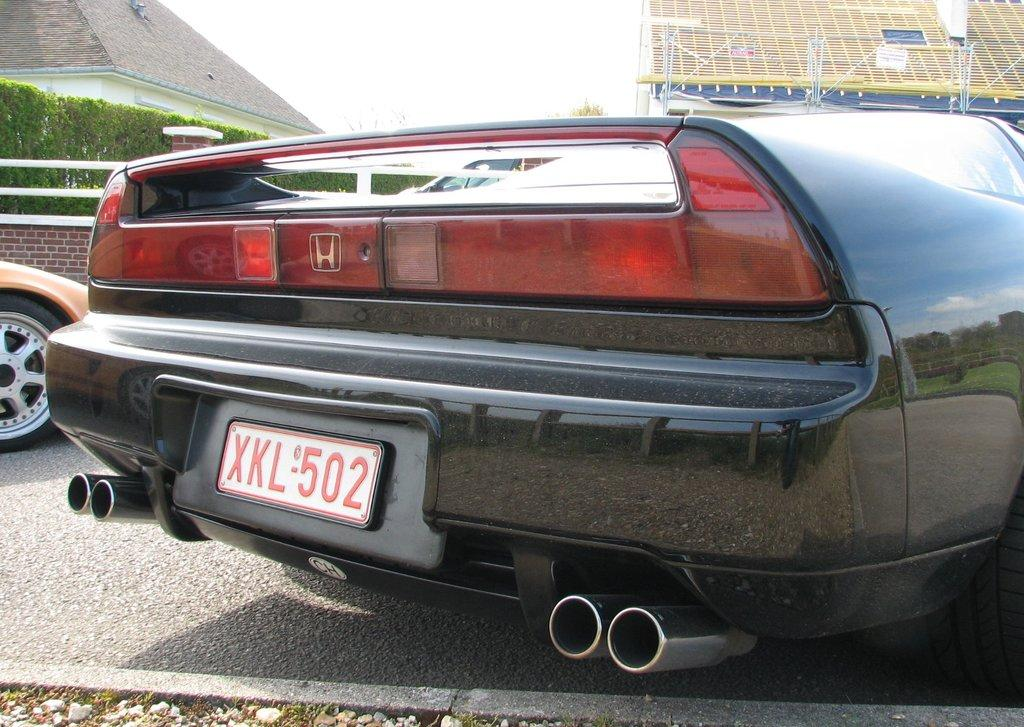What can be seen in the center of the image? There are cars on the road in the center of the image. What is visible in the background of the image? There are buildings and plants in the background of the image. What is at the bottom of the image? There is a road at the bottom of the image. What type of calendar is hanging on the wall in the image? There is no calendar present in the image; it features cars on a road, buildings and plants in the background, and a road at the bottom. How is the division of labor represented in the image? The image does not depict any division of labor; it is a scene of cars on a road, buildings and plants in the background, and a road at the bottom. 